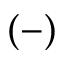<formula> <loc_0><loc_0><loc_500><loc_500>( - )</formula> 